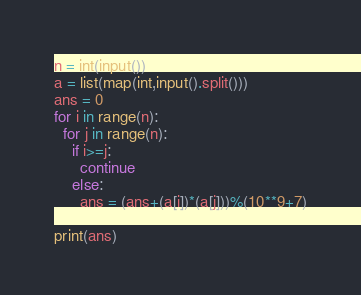<code> <loc_0><loc_0><loc_500><loc_500><_Python_>n = int(input())
a = list(map(int,input().split()))
ans = 0
for i in range(n):
  for j in range(n):
    if i>=j:
      continue
    else:
      ans = (ans+(a[i])*(a[j]))%(10**9+7)

print(ans)</code> 